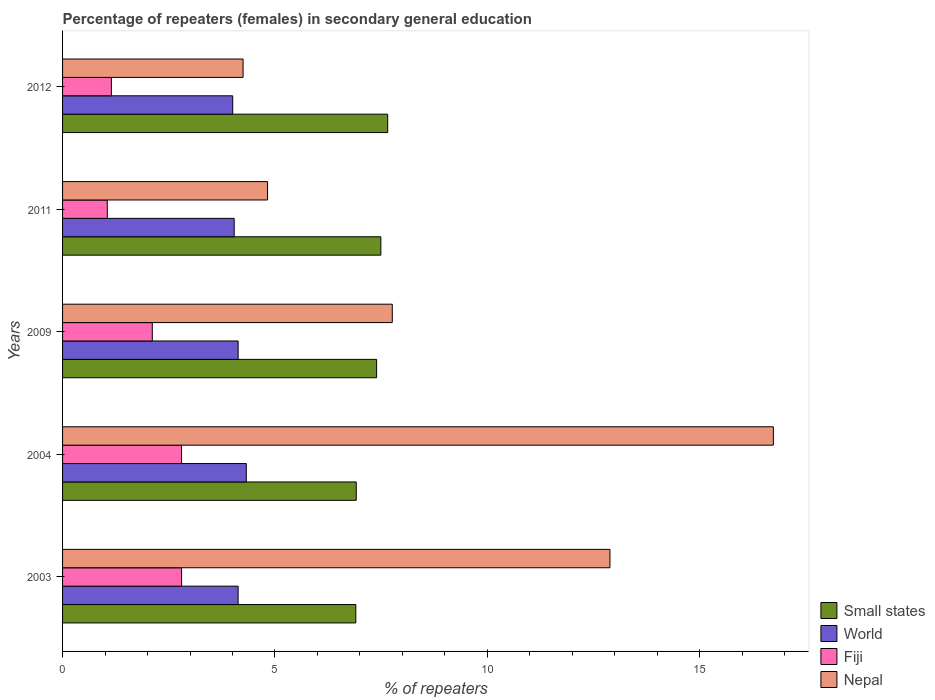How many groups of bars are there?
Provide a succinct answer. 5. Are the number of bars per tick equal to the number of legend labels?
Provide a succinct answer. Yes. How many bars are there on the 1st tick from the top?
Offer a terse response. 4. How many bars are there on the 5th tick from the bottom?
Your answer should be very brief. 4. What is the percentage of female repeaters in Small states in 2009?
Give a very brief answer. 7.39. Across all years, what is the maximum percentage of female repeaters in Small states?
Ensure brevity in your answer.  7.65. Across all years, what is the minimum percentage of female repeaters in World?
Ensure brevity in your answer.  4.01. In which year was the percentage of female repeaters in Small states maximum?
Your response must be concise. 2012. What is the total percentage of female repeaters in Small states in the graph?
Provide a succinct answer. 36.35. What is the difference between the percentage of female repeaters in Nepal in 2003 and that in 2004?
Your answer should be compact. -3.85. What is the difference between the percentage of female repeaters in Nepal in 2011 and the percentage of female repeaters in Small states in 2012?
Provide a succinct answer. -2.83. What is the average percentage of female repeaters in Nepal per year?
Your response must be concise. 9.29. In the year 2009, what is the difference between the percentage of female repeaters in World and percentage of female repeaters in Small states?
Your answer should be very brief. -3.26. In how many years, is the percentage of female repeaters in Fiji greater than 12 %?
Provide a succinct answer. 0. What is the ratio of the percentage of female repeaters in Fiji in 2003 to that in 2004?
Offer a terse response. 1. What is the difference between the highest and the second highest percentage of female repeaters in Nepal?
Your response must be concise. 3.85. What is the difference between the highest and the lowest percentage of female repeaters in Nepal?
Provide a short and direct response. 12.48. What does the 4th bar from the top in 2003 represents?
Offer a very short reply. Small states. Are all the bars in the graph horizontal?
Provide a short and direct response. Yes. What is the difference between two consecutive major ticks on the X-axis?
Ensure brevity in your answer.  5. Does the graph contain any zero values?
Give a very brief answer. No. Does the graph contain grids?
Your answer should be compact. No. How are the legend labels stacked?
Provide a succinct answer. Vertical. What is the title of the graph?
Provide a short and direct response. Percentage of repeaters (females) in secondary general education. What is the label or title of the X-axis?
Ensure brevity in your answer.  % of repeaters. What is the % of repeaters of Small states in 2003?
Provide a succinct answer. 6.9. What is the % of repeaters of World in 2003?
Keep it short and to the point. 4.13. What is the % of repeaters in Fiji in 2003?
Offer a terse response. 2.8. What is the % of repeaters in Nepal in 2003?
Provide a short and direct response. 12.88. What is the % of repeaters in Small states in 2004?
Ensure brevity in your answer.  6.91. What is the % of repeaters in World in 2004?
Your response must be concise. 4.33. What is the % of repeaters of Fiji in 2004?
Provide a succinct answer. 2.8. What is the % of repeaters of Nepal in 2004?
Make the answer very short. 16.73. What is the % of repeaters of Small states in 2009?
Your response must be concise. 7.39. What is the % of repeaters in World in 2009?
Offer a very short reply. 4.13. What is the % of repeaters in Fiji in 2009?
Your answer should be very brief. 2.11. What is the % of repeaters of Nepal in 2009?
Keep it short and to the point. 7.76. What is the % of repeaters in Small states in 2011?
Provide a succinct answer. 7.49. What is the % of repeaters in World in 2011?
Provide a succinct answer. 4.04. What is the % of repeaters of Fiji in 2011?
Offer a terse response. 1.05. What is the % of repeaters in Nepal in 2011?
Your answer should be very brief. 4.83. What is the % of repeaters of Small states in 2012?
Make the answer very short. 7.65. What is the % of repeaters of World in 2012?
Your answer should be very brief. 4.01. What is the % of repeaters in Fiji in 2012?
Offer a terse response. 1.15. What is the % of repeaters of Nepal in 2012?
Ensure brevity in your answer.  4.25. Across all years, what is the maximum % of repeaters in Small states?
Ensure brevity in your answer.  7.65. Across all years, what is the maximum % of repeaters in World?
Offer a terse response. 4.33. Across all years, what is the maximum % of repeaters in Fiji?
Offer a very short reply. 2.8. Across all years, what is the maximum % of repeaters in Nepal?
Offer a terse response. 16.73. Across all years, what is the minimum % of repeaters of Small states?
Your answer should be compact. 6.9. Across all years, what is the minimum % of repeaters in World?
Provide a short and direct response. 4.01. Across all years, what is the minimum % of repeaters of Fiji?
Your response must be concise. 1.05. Across all years, what is the minimum % of repeaters in Nepal?
Your response must be concise. 4.25. What is the total % of repeaters of Small states in the graph?
Offer a terse response. 36.35. What is the total % of repeaters in World in the graph?
Provide a succinct answer. 20.64. What is the total % of repeaters of Fiji in the graph?
Make the answer very short. 9.92. What is the total % of repeaters in Nepal in the graph?
Offer a terse response. 46.45. What is the difference between the % of repeaters of Small states in 2003 and that in 2004?
Offer a very short reply. -0.01. What is the difference between the % of repeaters of World in 2003 and that in 2004?
Ensure brevity in your answer.  -0.19. What is the difference between the % of repeaters of Fiji in 2003 and that in 2004?
Keep it short and to the point. 0. What is the difference between the % of repeaters in Nepal in 2003 and that in 2004?
Make the answer very short. -3.85. What is the difference between the % of repeaters in Small states in 2003 and that in 2009?
Offer a very short reply. -0.49. What is the difference between the % of repeaters in World in 2003 and that in 2009?
Provide a succinct answer. -0. What is the difference between the % of repeaters in Fiji in 2003 and that in 2009?
Your answer should be very brief. 0.69. What is the difference between the % of repeaters in Nepal in 2003 and that in 2009?
Offer a very short reply. 5.12. What is the difference between the % of repeaters in Small states in 2003 and that in 2011?
Offer a very short reply. -0.59. What is the difference between the % of repeaters of World in 2003 and that in 2011?
Keep it short and to the point. 0.09. What is the difference between the % of repeaters in Fiji in 2003 and that in 2011?
Offer a terse response. 1.75. What is the difference between the % of repeaters in Nepal in 2003 and that in 2011?
Make the answer very short. 8.06. What is the difference between the % of repeaters in Small states in 2003 and that in 2012?
Provide a succinct answer. -0.75. What is the difference between the % of repeaters of World in 2003 and that in 2012?
Keep it short and to the point. 0.13. What is the difference between the % of repeaters in Fiji in 2003 and that in 2012?
Offer a very short reply. 1.65. What is the difference between the % of repeaters of Nepal in 2003 and that in 2012?
Give a very brief answer. 8.64. What is the difference between the % of repeaters in Small states in 2004 and that in 2009?
Provide a succinct answer. -0.48. What is the difference between the % of repeaters in World in 2004 and that in 2009?
Your response must be concise. 0.19. What is the difference between the % of repeaters of Fiji in 2004 and that in 2009?
Offer a very short reply. 0.69. What is the difference between the % of repeaters in Nepal in 2004 and that in 2009?
Provide a short and direct response. 8.97. What is the difference between the % of repeaters in Small states in 2004 and that in 2011?
Ensure brevity in your answer.  -0.58. What is the difference between the % of repeaters of World in 2004 and that in 2011?
Your answer should be compact. 0.29. What is the difference between the % of repeaters in Fiji in 2004 and that in 2011?
Make the answer very short. 1.75. What is the difference between the % of repeaters in Nepal in 2004 and that in 2011?
Offer a terse response. 11.91. What is the difference between the % of repeaters in Small states in 2004 and that in 2012?
Ensure brevity in your answer.  -0.74. What is the difference between the % of repeaters in World in 2004 and that in 2012?
Your answer should be very brief. 0.32. What is the difference between the % of repeaters in Fiji in 2004 and that in 2012?
Keep it short and to the point. 1.65. What is the difference between the % of repeaters in Nepal in 2004 and that in 2012?
Ensure brevity in your answer.  12.48. What is the difference between the % of repeaters in Small states in 2009 and that in 2011?
Make the answer very short. -0.1. What is the difference between the % of repeaters in World in 2009 and that in 2011?
Your response must be concise. 0.09. What is the difference between the % of repeaters of Fiji in 2009 and that in 2011?
Keep it short and to the point. 1.06. What is the difference between the % of repeaters of Nepal in 2009 and that in 2011?
Your answer should be compact. 2.94. What is the difference between the % of repeaters of Small states in 2009 and that in 2012?
Provide a short and direct response. -0.26. What is the difference between the % of repeaters in World in 2009 and that in 2012?
Ensure brevity in your answer.  0.13. What is the difference between the % of repeaters of Fiji in 2009 and that in 2012?
Provide a succinct answer. 0.96. What is the difference between the % of repeaters in Nepal in 2009 and that in 2012?
Provide a short and direct response. 3.51. What is the difference between the % of repeaters of Small states in 2011 and that in 2012?
Offer a very short reply. -0.16. What is the difference between the % of repeaters in World in 2011 and that in 2012?
Your answer should be compact. 0.03. What is the difference between the % of repeaters in Fiji in 2011 and that in 2012?
Make the answer very short. -0.1. What is the difference between the % of repeaters of Nepal in 2011 and that in 2012?
Your answer should be very brief. 0.58. What is the difference between the % of repeaters in Small states in 2003 and the % of repeaters in World in 2004?
Offer a terse response. 2.58. What is the difference between the % of repeaters of Small states in 2003 and the % of repeaters of Fiji in 2004?
Keep it short and to the point. 4.1. What is the difference between the % of repeaters in Small states in 2003 and the % of repeaters in Nepal in 2004?
Provide a short and direct response. -9.83. What is the difference between the % of repeaters of World in 2003 and the % of repeaters of Fiji in 2004?
Your response must be concise. 1.33. What is the difference between the % of repeaters in World in 2003 and the % of repeaters in Nepal in 2004?
Give a very brief answer. -12.6. What is the difference between the % of repeaters in Fiji in 2003 and the % of repeaters in Nepal in 2004?
Your answer should be compact. -13.93. What is the difference between the % of repeaters of Small states in 2003 and the % of repeaters of World in 2009?
Provide a succinct answer. 2.77. What is the difference between the % of repeaters of Small states in 2003 and the % of repeaters of Fiji in 2009?
Ensure brevity in your answer.  4.79. What is the difference between the % of repeaters in Small states in 2003 and the % of repeaters in Nepal in 2009?
Keep it short and to the point. -0.86. What is the difference between the % of repeaters in World in 2003 and the % of repeaters in Fiji in 2009?
Give a very brief answer. 2.02. What is the difference between the % of repeaters of World in 2003 and the % of repeaters of Nepal in 2009?
Ensure brevity in your answer.  -3.63. What is the difference between the % of repeaters of Fiji in 2003 and the % of repeaters of Nepal in 2009?
Offer a terse response. -4.96. What is the difference between the % of repeaters of Small states in 2003 and the % of repeaters of World in 2011?
Make the answer very short. 2.86. What is the difference between the % of repeaters in Small states in 2003 and the % of repeaters in Fiji in 2011?
Provide a short and direct response. 5.85. What is the difference between the % of repeaters in Small states in 2003 and the % of repeaters in Nepal in 2011?
Give a very brief answer. 2.08. What is the difference between the % of repeaters in World in 2003 and the % of repeaters in Fiji in 2011?
Offer a very short reply. 3.08. What is the difference between the % of repeaters in World in 2003 and the % of repeaters in Nepal in 2011?
Provide a short and direct response. -0.69. What is the difference between the % of repeaters of Fiji in 2003 and the % of repeaters of Nepal in 2011?
Make the answer very short. -2.02. What is the difference between the % of repeaters of Small states in 2003 and the % of repeaters of World in 2012?
Your answer should be very brief. 2.9. What is the difference between the % of repeaters in Small states in 2003 and the % of repeaters in Fiji in 2012?
Provide a short and direct response. 5.75. What is the difference between the % of repeaters of Small states in 2003 and the % of repeaters of Nepal in 2012?
Offer a terse response. 2.65. What is the difference between the % of repeaters in World in 2003 and the % of repeaters in Fiji in 2012?
Offer a terse response. 2.98. What is the difference between the % of repeaters of World in 2003 and the % of repeaters of Nepal in 2012?
Your answer should be very brief. -0.12. What is the difference between the % of repeaters in Fiji in 2003 and the % of repeaters in Nepal in 2012?
Ensure brevity in your answer.  -1.45. What is the difference between the % of repeaters of Small states in 2004 and the % of repeaters of World in 2009?
Offer a terse response. 2.78. What is the difference between the % of repeaters of Small states in 2004 and the % of repeaters of Fiji in 2009?
Your answer should be compact. 4.8. What is the difference between the % of repeaters of Small states in 2004 and the % of repeaters of Nepal in 2009?
Your answer should be very brief. -0.85. What is the difference between the % of repeaters in World in 2004 and the % of repeaters in Fiji in 2009?
Ensure brevity in your answer.  2.21. What is the difference between the % of repeaters in World in 2004 and the % of repeaters in Nepal in 2009?
Offer a terse response. -3.44. What is the difference between the % of repeaters of Fiji in 2004 and the % of repeaters of Nepal in 2009?
Provide a succinct answer. -4.96. What is the difference between the % of repeaters in Small states in 2004 and the % of repeaters in World in 2011?
Give a very brief answer. 2.87. What is the difference between the % of repeaters of Small states in 2004 and the % of repeaters of Fiji in 2011?
Offer a very short reply. 5.86. What is the difference between the % of repeaters in Small states in 2004 and the % of repeaters in Nepal in 2011?
Offer a very short reply. 2.09. What is the difference between the % of repeaters in World in 2004 and the % of repeaters in Fiji in 2011?
Provide a succinct answer. 3.27. What is the difference between the % of repeaters in World in 2004 and the % of repeaters in Nepal in 2011?
Your response must be concise. -0.5. What is the difference between the % of repeaters in Fiji in 2004 and the % of repeaters in Nepal in 2011?
Provide a short and direct response. -2.02. What is the difference between the % of repeaters of Small states in 2004 and the % of repeaters of World in 2012?
Provide a short and direct response. 2.91. What is the difference between the % of repeaters in Small states in 2004 and the % of repeaters in Fiji in 2012?
Your response must be concise. 5.76. What is the difference between the % of repeaters of Small states in 2004 and the % of repeaters of Nepal in 2012?
Your response must be concise. 2.66. What is the difference between the % of repeaters in World in 2004 and the % of repeaters in Fiji in 2012?
Your response must be concise. 3.18. What is the difference between the % of repeaters in World in 2004 and the % of repeaters in Nepal in 2012?
Offer a terse response. 0.08. What is the difference between the % of repeaters of Fiji in 2004 and the % of repeaters of Nepal in 2012?
Offer a terse response. -1.45. What is the difference between the % of repeaters of Small states in 2009 and the % of repeaters of World in 2011?
Provide a succinct answer. 3.35. What is the difference between the % of repeaters of Small states in 2009 and the % of repeaters of Fiji in 2011?
Offer a terse response. 6.34. What is the difference between the % of repeaters of Small states in 2009 and the % of repeaters of Nepal in 2011?
Ensure brevity in your answer.  2.57. What is the difference between the % of repeaters of World in 2009 and the % of repeaters of Fiji in 2011?
Provide a succinct answer. 3.08. What is the difference between the % of repeaters of World in 2009 and the % of repeaters of Nepal in 2011?
Give a very brief answer. -0.69. What is the difference between the % of repeaters in Fiji in 2009 and the % of repeaters in Nepal in 2011?
Give a very brief answer. -2.71. What is the difference between the % of repeaters of Small states in 2009 and the % of repeaters of World in 2012?
Offer a very short reply. 3.39. What is the difference between the % of repeaters of Small states in 2009 and the % of repeaters of Fiji in 2012?
Make the answer very short. 6.24. What is the difference between the % of repeaters in Small states in 2009 and the % of repeaters in Nepal in 2012?
Keep it short and to the point. 3.14. What is the difference between the % of repeaters in World in 2009 and the % of repeaters in Fiji in 2012?
Your response must be concise. 2.98. What is the difference between the % of repeaters in World in 2009 and the % of repeaters in Nepal in 2012?
Offer a terse response. -0.12. What is the difference between the % of repeaters in Fiji in 2009 and the % of repeaters in Nepal in 2012?
Your answer should be compact. -2.14. What is the difference between the % of repeaters of Small states in 2011 and the % of repeaters of World in 2012?
Your answer should be very brief. 3.49. What is the difference between the % of repeaters in Small states in 2011 and the % of repeaters in Fiji in 2012?
Your response must be concise. 6.34. What is the difference between the % of repeaters of Small states in 2011 and the % of repeaters of Nepal in 2012?
Keep it short and to the point. 3.24. What is the difference between the % of repeaters in World in 2011 and the % of repeaters in Fiji in 2012?
Provide a succinct answer. 2.89. What is the difference between the % of repeaters of World in 2011 and the % of repeaters of Nepal in 2012?
Provide a short and direct response. -0.21. What is the difference between the % of repeaters in Fiji in 2011 and the % of repeaters in Nepal in 2012?
Make the answer very short. -3.2. What is the average % of repeaters in Small states per year?
Provide a short and direct response. 7.27. What is the average % of repeaters in World per year?
Your answer should be compact. 4.13. What is the average % of repeaters in Fiji per year?
Make the answer very short. 1.98. What is the average % of repeaters in Nepal per year?
Offer a terse response. 9.29. In the year 2003, what is the difference between the % of repeaters in Small states and % of repeaters in World?
Provide a short and direct response. 2.77. In the year 2003, what is the difference between the % of repeaters in Small states and % of repeaters in Fiji?
Keep it short and to the point. 4.1. In the year 2003, what is the difference between the % of repeaters of Small states and % of repeaters of Nepal?
Your answer should be compact. -5.98. In the year 2003, what is the difference between the % of repeaters in World and % of repeaters in Fiji?
Your response must be concise. 1.33. In the year 2003, what is the difference between the % of repeaters in World and % of repeaters in Nepal?
Make the answer very short. -8.75. In the year 2003, what is the difference between the % of repeaters in Fiji and % of repeaters in Nepal?
Offer a terse response. -10.08. In the year 2004, what is the difference between the % of repeaters in Small states and % of repeaters in World?
Give a very brief answer. 2.59. In the year 2004, what is the difference between the % of repeaters of Small states and % of repeaters of Fiji?
Your response must be concise. 4.11. In the year 2004, what is the difference between the % of repeaters in Small states and % of repeaters in Nepal?
Provide a short and direct response. -9.82. In the year 2004, what is the difference between the % of repeaters of World and % of repeaters of Fiji?
Keep it short and to the point. 1.52. In the year 2004, what is the difference between the % of repeaters in World and % of repeaters in Nepal?
Keep it short and to the point. -12.41. In the year 2004, what is the difference between the % of repeaters in Fiji and % of repeaters in Nepal?
Your answer should be very brief. -13.93. In the year 2009, what is the difference between the % of repeaters in Small states and % of repeaters in World?
Ensure brevity in your answer.  3.26. In the year 2009, what is the difference between the % of repeaters of Small states and % of repeaters of Fiji?
Your answer should be compact. 5.28. In the year 2009, what is the difference between the % of repeaters in Small states and % of repeaters in Nepal?
Offer a terse response. -0.37. In the year 2009, what is the difference between the % of repeaters of World and % of repeaters of Fiji?
Your answer should be compact. 2.02. In the year 2009, what is the difference between the % of repeaters in World and % of repeaters in Nepal?
Your answer should be very brief. -3.63. In the year 2009, what is the difference between the % of repeaters of Fiji and % of repeaters of Nepal?
Make the answer very short. -5.65. In the year 2011, what is the difference between the % of repeaters of Small states and % of repeaters of World?
Your answer should be compact. 3.45. In the year 2011, what is the difference between the % of repeaters in Small states and % of repeaters in Fiji?
Your answer should be very brief. 6.44. In the year 2011, what is the difference between the % of repeaters in Small states and % of repeaters in Nepal?
Your response must be concise. 2.67. In the year 2011, what is the difference between the % of repeaters of World and % of repeaters of Fiji?
Keep it short and to the point. 2.99. In the year 2011, what is the difference between the % of repeaters in World and % of repeaters in Nepal?
Offer a very short reply. -0.79. In the year 2011, what is the difference between the % of repeaters in Fiji and % of repeaters in Nepal?
Your response must be concise. -3.77. In the year 2012, what is the difference between the % of repeaters of Small states and % of repeaters of World?
Your response must be concise. 3.65. In the year 2012, what is the difference between the % of repeaters in Small states and % of repeaters in Fiji?
Keep it short and to the point. 6.5. In the year 2012, what is the difference between the % of repeaters in Small states and % of repeaters in Nepal?
Offer a very short reply. 3.4. In the year 2012, what is the difference between the % of repeaters in World and % of repeaters in Fiji?
Ensure brevity in your answer.  2.86. In the year 2012, what is the difference between the % of repeaters of World and % of repeaters of Nepal?
Give a very brief answer. -0.24. In the year 2012, what is the difference between the % of repeaters in Fiji and % of repeaters in Nepal?
Your response must be concise. -3.1. What is the ratio of the % of repeaters in World in 2003 to that in 2004?
Provide a short and direct response. 0.96. What is the ratio of the % of repeaters in Fiji in 2003 to that in 2004?
Keep it short and to the point. 1. What is the ratio of the % of repeaters in Nepal in 2003 to that in 2004?
Keep it short and to the point. 0.77. What is the ratio of the % of repeaters in Small states in 2003 to that in 2009?
Keep it short and to the point. 0.93. What is the ratio of the % of repeaters of World in 2003 to that in 2009?
Offer a terse response. 1. What is the ratio of the % of repeaters of Fiji in 2003 to that in 2009?
Keep it short and to the point. 1.33. What is the ratio of the % of repeaters in Nepal in 2003 to that in 2009?
Your answer should be very brief. 1.66. What is the ratio of the % of repeaters in Small states in 2003 to that in 2011?
Your answer should be very brief. 0.92. What is the ratio of the % of repeaters in World in 2003 to that in 2011?
Make the answer very short. 1.02. What is the ratio of the % of repeaters in Fiji in 2003 to that in 2011?
Your response must be concise. 2.66. What is the ratio of the % of repeaters in Nepal in 2003 to that in 2011?
Offer a terse response. 2.67. What is the ratio of the % of repeaters in Small states in 2003 to that in 2012?
Your answer should be very brief. 0.9. What is the ratio of the % of repeaters of World in 2003 to that in 2012?
Make the answer very short. 1.03. What is the ratio of the % of repeaters in Fiji in 2003 to that in 2012?
Provide a short and direct response. 2.44. What is the ratio of the % of repeaters in Nepal in 2003 to that in 2012?
Keep it short and to the point. 3.03. What is the ratio of the % of repeaters of Small states in 2004 to that in 2009?
Your answer should be compact. 0.94. What is the ratio of the % of repeaters in World in 2004 to that in 2009?
Ensure brevity in your answer.  1.05. What is the ratio of the % of repeaters of Fiji in 2004 to that in 2009?
Provide a short and direct response. 1.33. What is the ratio of the % of repeaters in Nepal in 2004 to that in 2009?
Offer a terse response. 2.16. What is the ratio of the % of repeaters of Small states in 2004 to that in 2011?
Provide a short and direct response. 0.92. What is the ratio of the % of repeaters of World in 2004 to that in 2011?
Provide a short and direct response. 1.07. What is the ratio of the % of repeaters of Fiji in 2004 to that in 2011?
Give a very brief answer. 2.66. What is the ratio of the % of repeaters in Nepal in 2004 to that in 2011?
Keep it short and to the point. 3.47. What is the ratio of the % of repeaters of Small states in 2004 to that in 2012?
Provide a succinct answer. 0.9. What is the ratio of the % of repeaters in Fiji in 2004 to that in 2012?
Offer a terse response. 2.44. What is the ratio of the % of repeaters in Nepal in 2004 to that in 2012?
Offer a terse response. 3.94. What is the ratio of the % of repeaters in Small states in 2009 to that in 2011?
Offer a terse response. 0.99. What is the ratio of the % of repeaters in World in 2009 to that in 2011?
Provide a succinct answer. 1.02. What is the ratio of the % of repeaters of Fiji in 2009 to that in 2011?
Your answer should be compact. 2.01. What is the ratio of the % of repeaters in Nepal in 2009 to that in 2011?
Your response must be concise. 1.61. What is the ratio of the % of repeaters of World in 2009 to that in 2012?
Keep it short and to the point. 1.03. What is the ratio of the % of repeaters of Fiji in 2009 to that in 2012?
Offer a terse response. 1.84. What is the ratio of the % of repeaters of Nepal in 2009 to that in 2012?
Your answer should be very brief. 1.83. What is the ratio of the % of repeaters in World in 2011 to that in 2012?
Offer a very short reply. 1.01. What is the ratio of the % of repeaters in Fiji in 2011 to that in 2012?
Offer a very short reply. 0.92. What is the ratio of the % of repeaters of Nepal in 2011 to that in 2012?
Provide a short and direct response. 1.14. What is the difference between the highest and the second highest % of repeaters in Small states?
Provide a succinct answer. 0.16. What is the difference between the highest and the second highest % of repeaters of World?
Provide a succinct answer. 0.19. What is the difference between the highest and the second highest % of repeaters of Nepal?
Your answer should be very brief. 3.85. What is the difference between the highest and the lowest % of repeaters of Small states?
Give a very brief answer. 0.75. What is the difference between the highest and the lowest % of repeaters in World?
Offer a terse response. 0.32. What is the difference between the highest and the lowest % of repeaters in Fiji?
Make the answer very short. 1.75. What is the difference between the highest and the lowest % of repeaters of Nepal?
Make the answer very short. 12.48. 